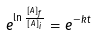Convert formula to latex. <formula><loc_0><loc_0><loc_500><loc_500>e ^ { \ln \frac { [ A ] _ { f } } { [ A ] _ { i } } } = e ^ { - k t }</formula> 